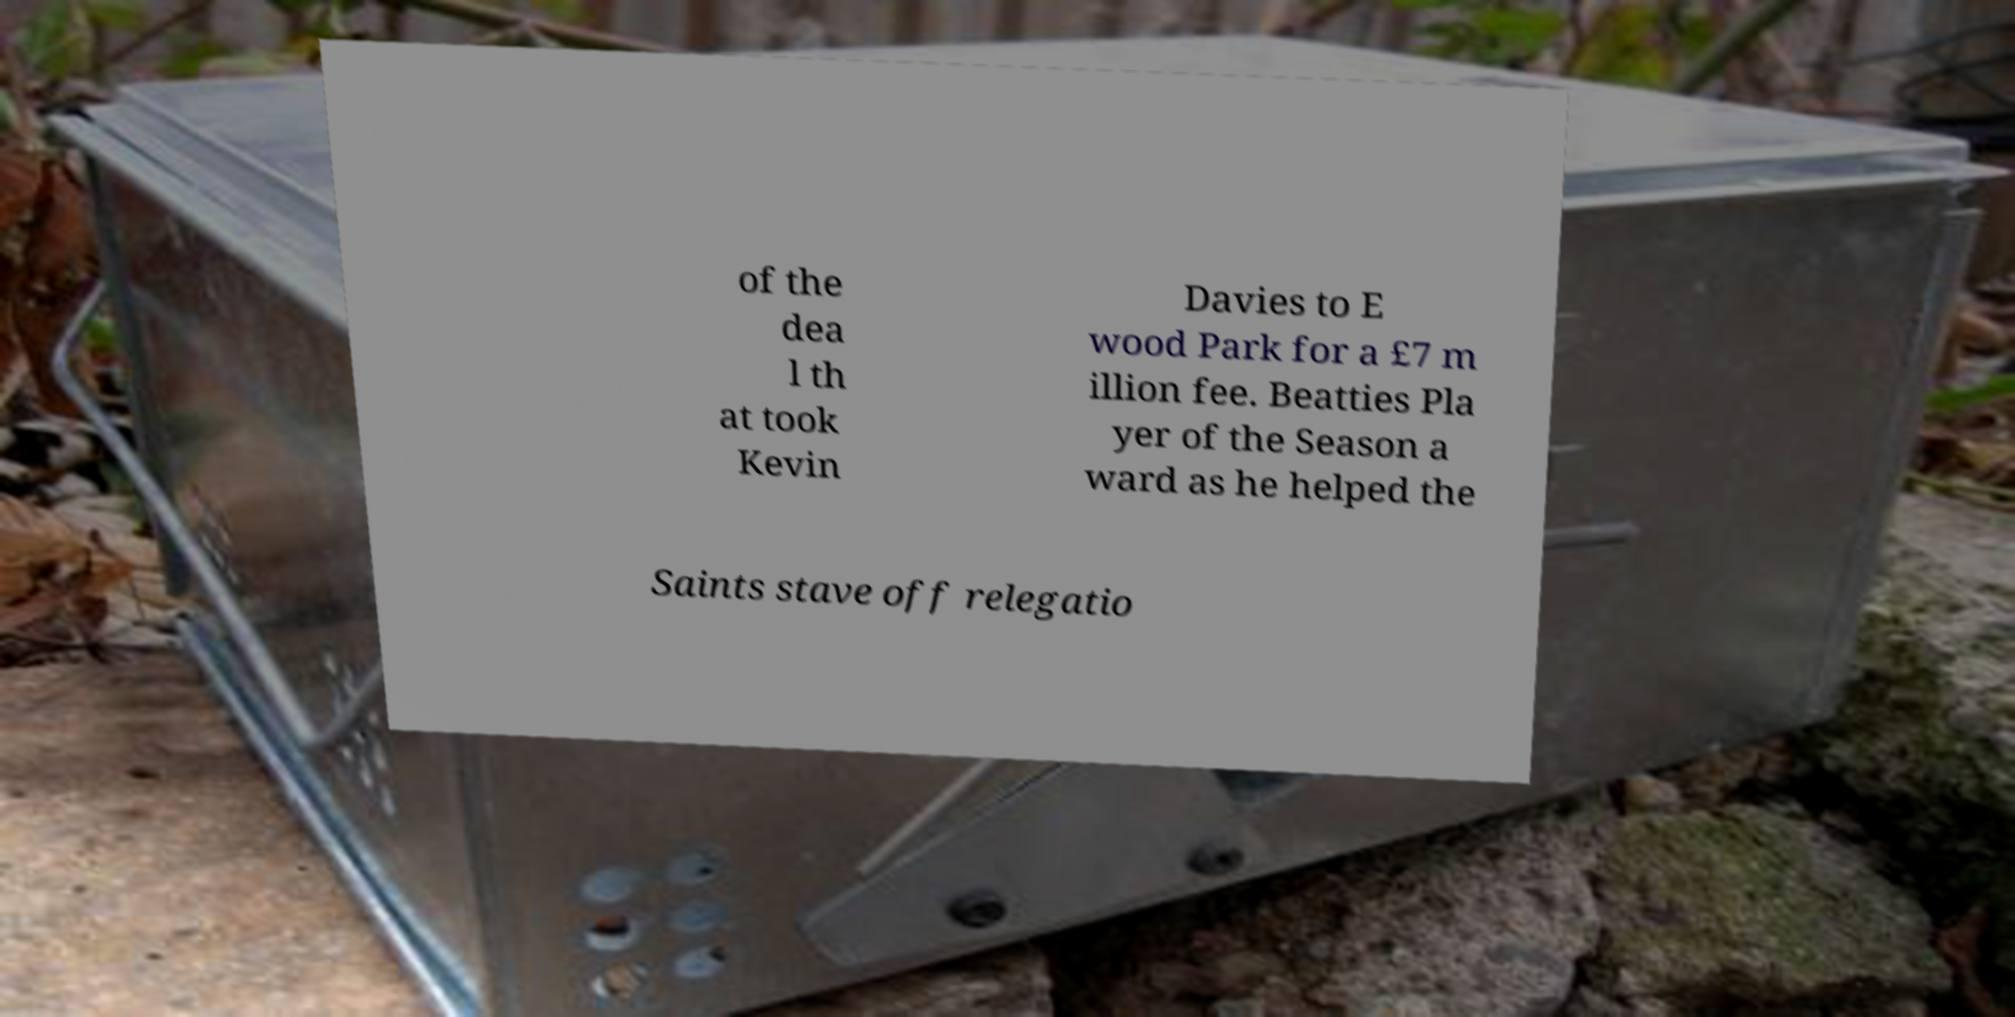Could you extract and type out the text from this image? of the dea l th at took Kevin Davies to E wood Park for a £7 m illion fee. Beatties Pla yer of the Season a ward as he helped the Saints stave off relegatio 